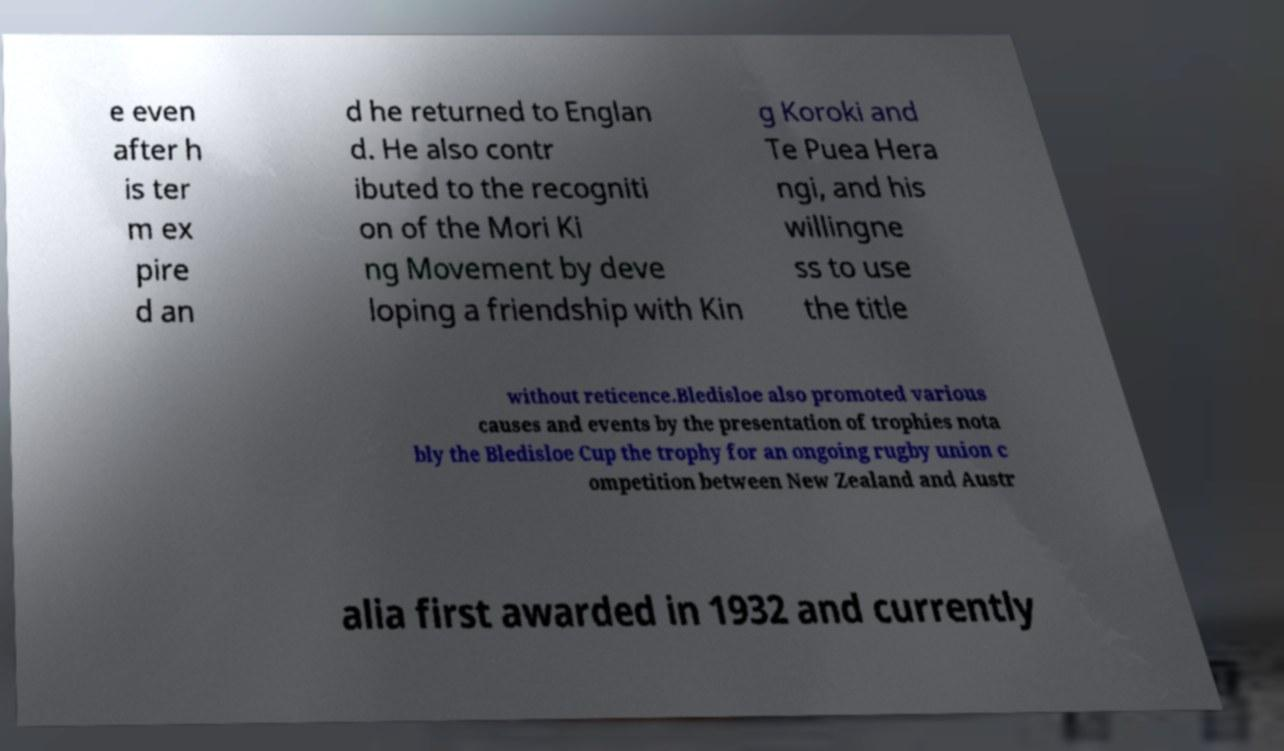For documentation purposes, I need the text within this image transcribed. Could you provide that? e even after h is ter m ex pire d an d he returned to Englan d. He also contr ibuted to the recogniti on of the Mori Ki ng Movement by deve loping a friendship with Kin g Koroki and Te Puea Hera ngi, and his willingne ss to use the title without reticence.Bledisloe also promoted various causes and events by the presentation of trophies nota bly the Bledisloe Cup the trophy for an ongoing rugby union c ompetition between New Zealand and Austr alia first awarded in 1932 and currently 